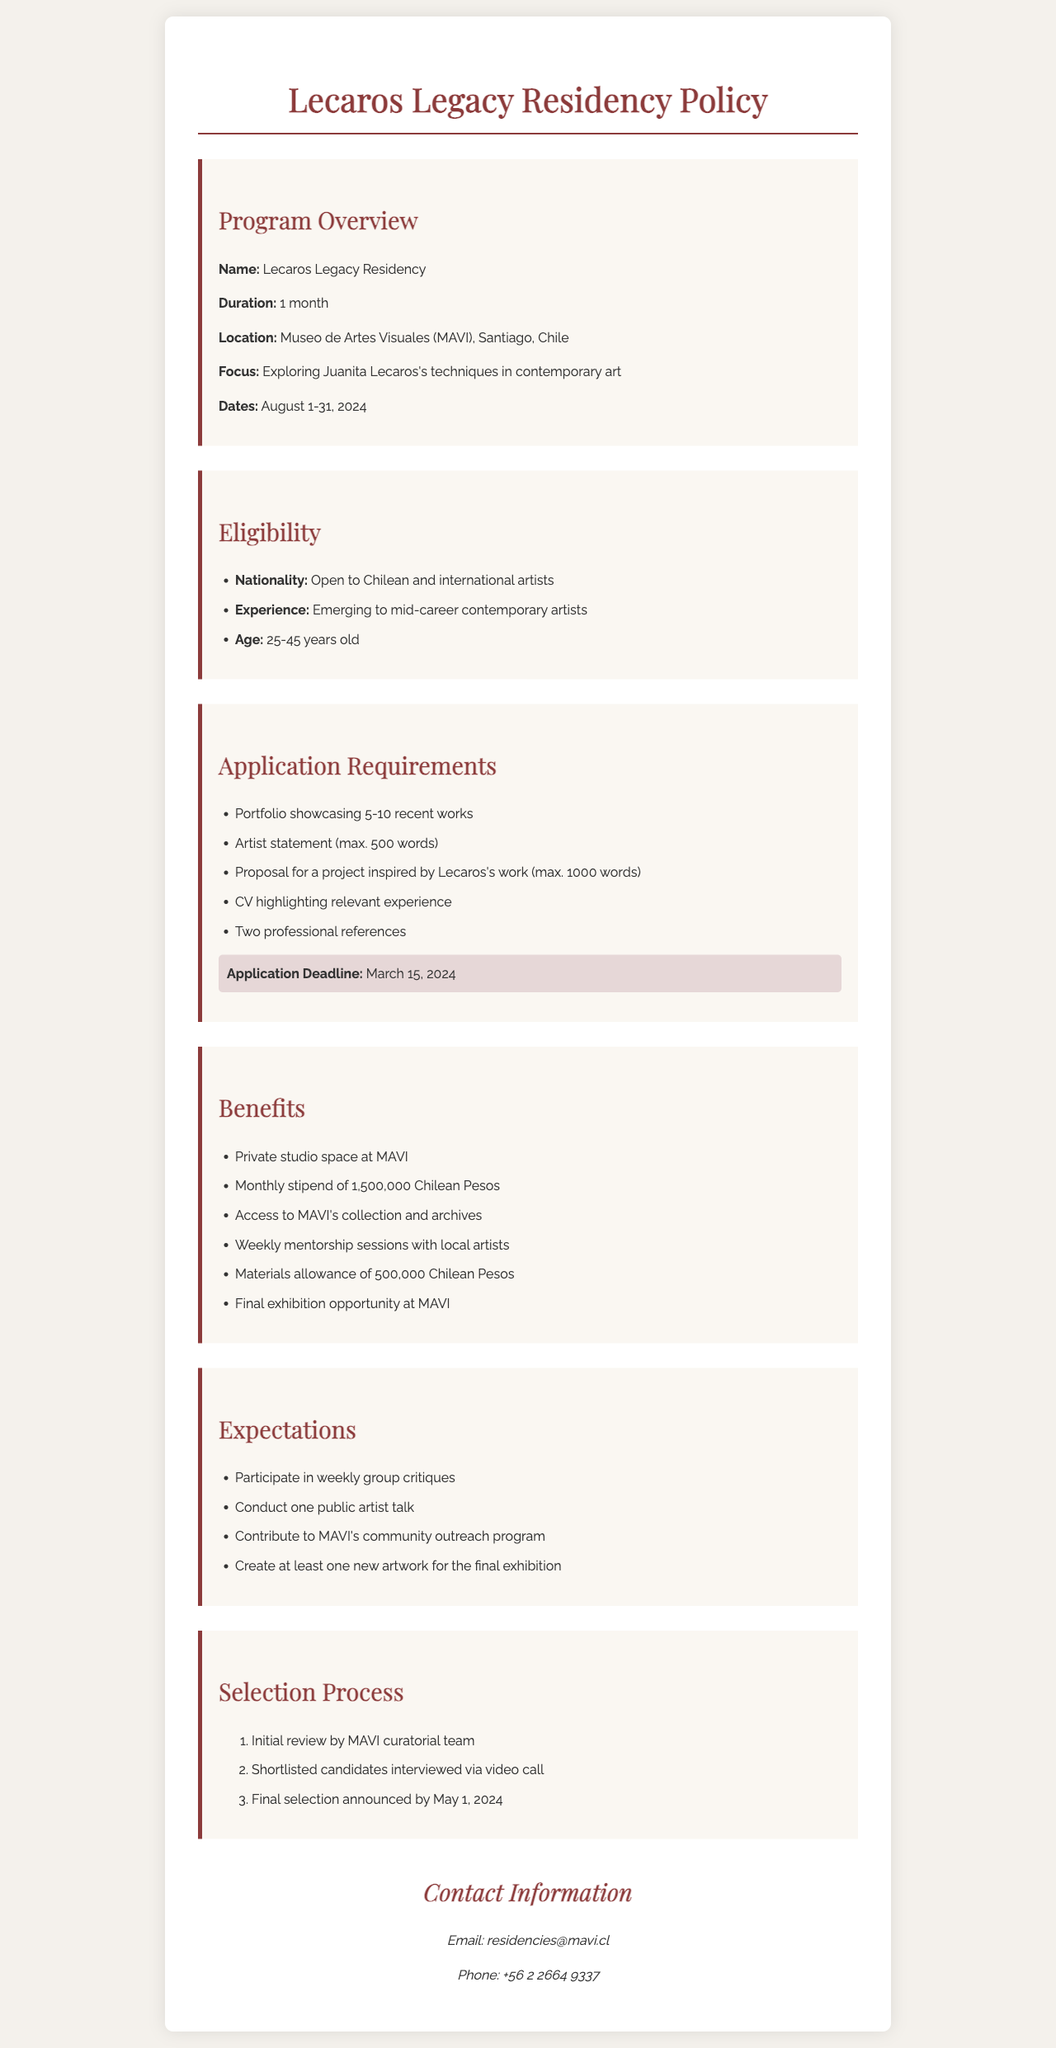What is the name of the residency program? The name of the residency program is mentioned in the document's overview section.
Answer: Lecaros Legacy Residency What is the duration of the residency? The duration is specified in the program overview section.
Answer: 1 month Where will the residency take place? The location of the residency is provided in the program overview section.
Answer: Museo de Artes Visuales (MAVI), Santiago, Chile What is the application deadline? The application deadline is highlighted in the application requirements section.
Answer: March 15, 2024 What is the stipend amount provided during the residency? The stipend amount is listed in the benefits section of the document.
Answer: 1,500,000 Chilean Pesos What is one of the expectations of participants in the residency? Expectations for participants are outlined in the expectations section.
Answer: Participate in weekly group critiques How old must applicants be to be eligible? Eligibility requirements related to age are found in the eligibility section.
Answer: 25-45 years old What type of artists is the residency program open to? The eligibility section specifies the type of artists who can apply.
Answer: Emerging to mid-career contemporary artists When will the final selection be announced? The date for the final selection announcement is detailed in the selection process section.
Answer: May 1, 2024 